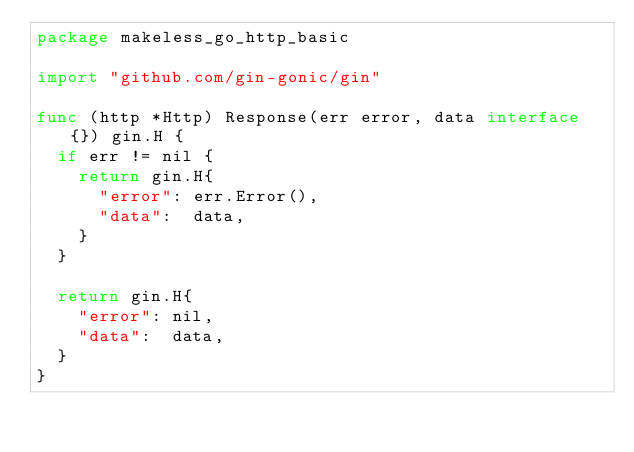<code> <loc_0><loc_0><loc_500><loc_500><_Go_>package makeless_go_http_basic

import "github.com/gin-gonic/gin"

func (http *Http) Response(err error, data interface{}) gin.H {
	if err != nil {
		return gin.H{
			"error": err.Error(),
			"data":  data,
		}
	}

	return gin.H{
		"error": nil,
		"data":  data,
	}
}
</code> 